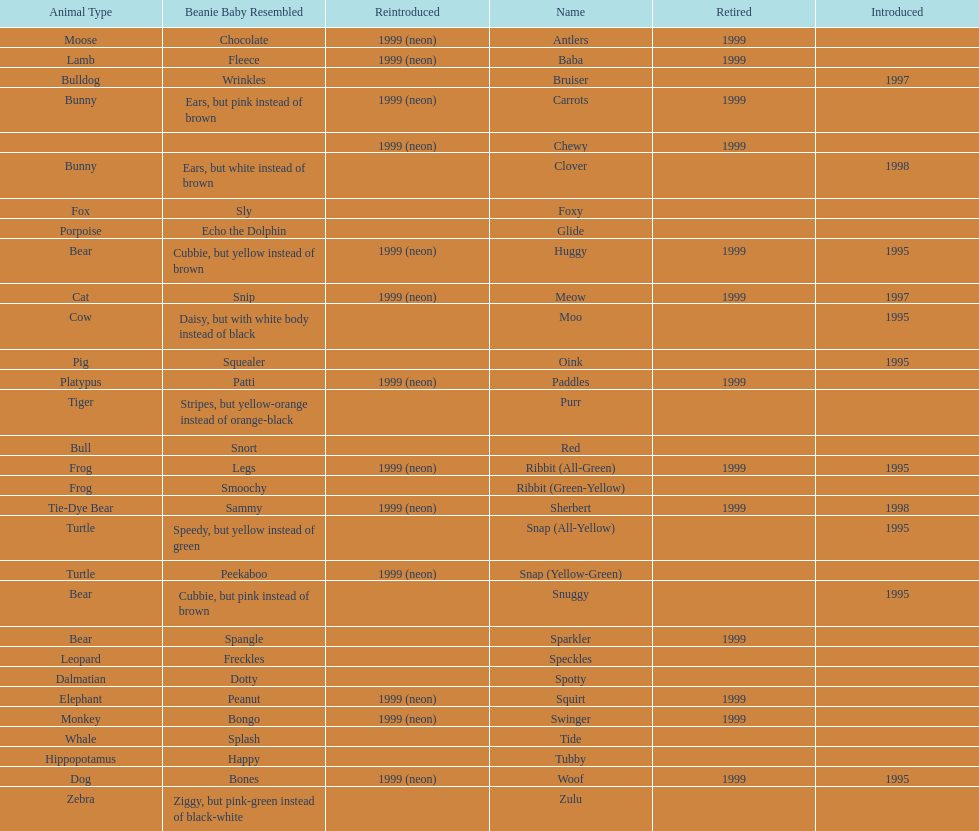State the amount of pillow pals brought back in 199 13. 